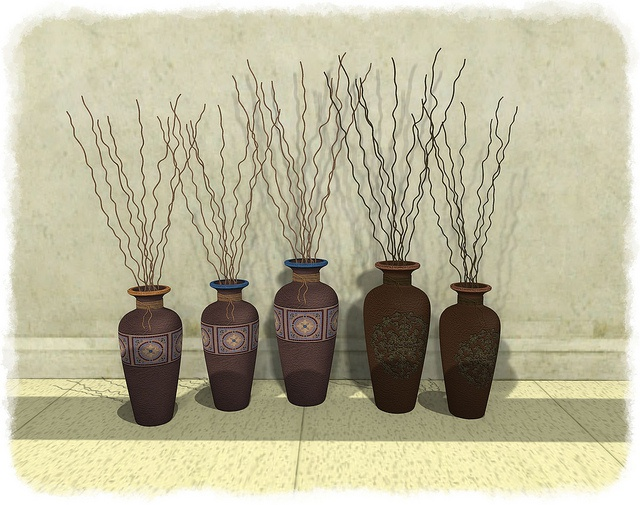Describe the objects in this image and their specific colors. I can see potted plant in white, beige, black, tan, and maroon tones, potted plant in white, beige, darkgray, maroon, and black tones, vase in white, black, and gray tones, vase in white, black, and gray tones, and vase in white, black, gray, and maroon tones in this image. 